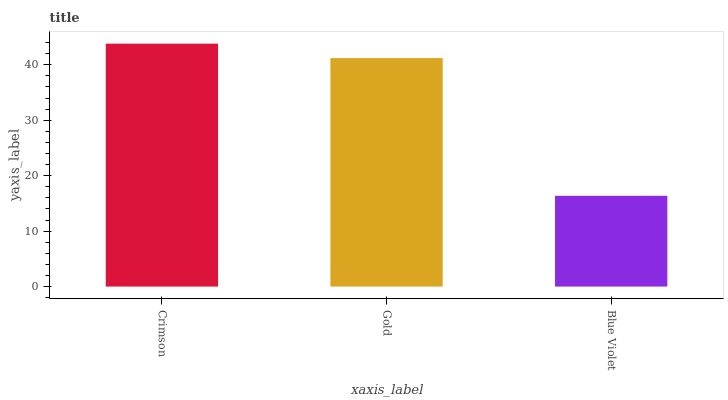Is Blue Violet the minimum?
Answer yes or no. Yes. Is Crimson the maximum?
Answer yes or no. Yes. Is Gold the minimum?
Answer yes or no. No. Is Gold the maximum?
Answer yes or no. No. Is Crimson greater than Gold?
Answer yes or no. Yes. Is Gold less than Crimson?
Answer yes or no. Yes. Is Gold greater than Crimson?
Answer yes or no. No. Is Crimson less than Gold?
Answer yes or no. No. Is Gold the high median?
Answer yes or no. Yes. Is Gold the low median?
Answer yes or no. Yes. Is Crimson the high median?
Answer yes or no. No. Is Blue Violet the low median?
Answer yes or no. No. 